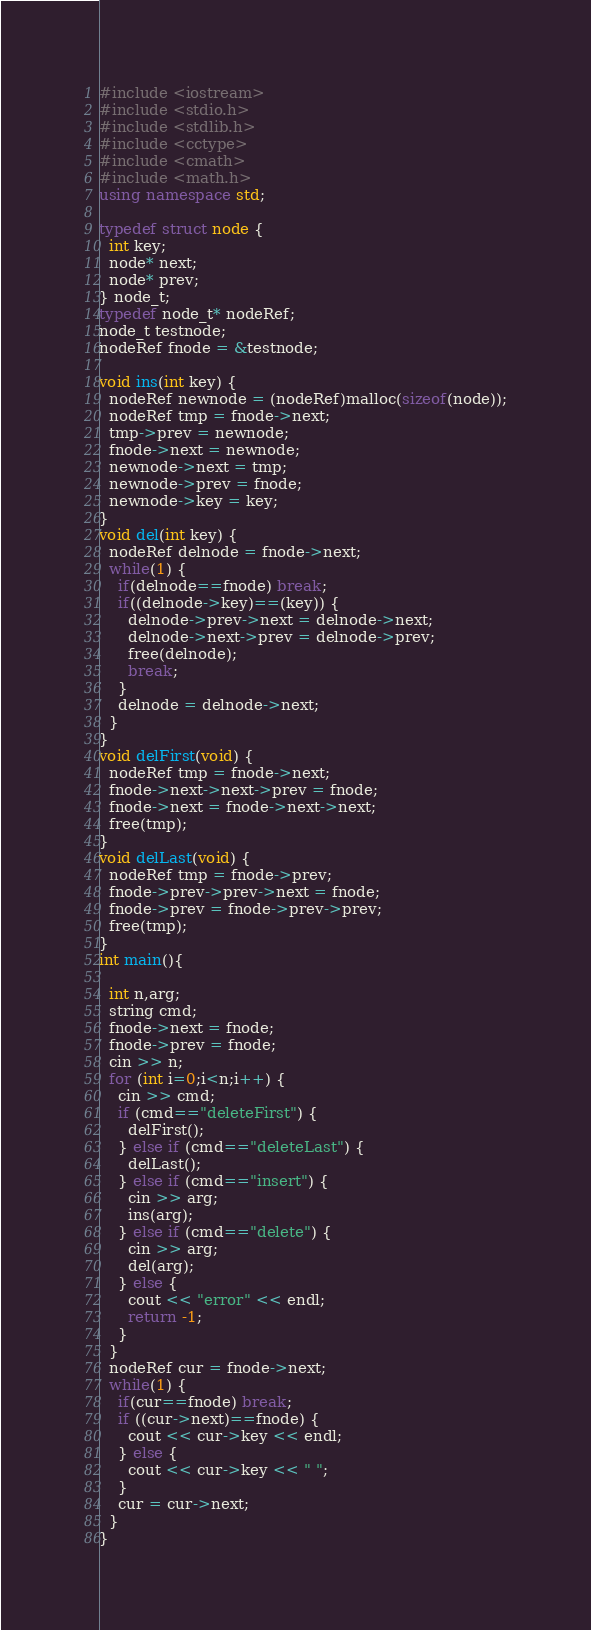Convert code to text. <code><loc_0><loc_0><loc_500><loc_500><_C++_>#include <iostream>
#include <stdio.h>
#include <stdlib.h>
#include <cctype>
#include <cmath>
#include <math.h>
using namespace std;

typedef struct node {
  int key;
  node* next;
  node* prev;
} node_t;
typedef node_t* nodeRef;
node_t testnode;
nodeRef fnode = &testnode;

void ins(int key) {
  nodeRef newnode = (nodeRef)malloc(sizeof(node));
  nodeRef tmp = fnode->next;
  tmp->prev = newnode;
  fnode->next = newnode;
  newnode->next = tmp;
  newnode->prev = fnode;
  newnode->key = key;
}
void del(int key) {
  nodeRef delnode = fnode->next;
  while(1) {
    if(delnode==fnode) break;
    if((delnode->key)==(key)) {
      delnode->prev->next = delnode->next;
      delnode->next->prev = delnode->prev;
      free(delnode);
      break;
    }
    delnode = delnode->next;
  }
}
void delFirst(void) {
  nodeRef tmp = fnode->next;
  fnode->next->next->prev = fnode;
  fnode->next = fnode->next->next;
  free(tmp);
}
void delLast(void) {
  nodeRef tmp = fnode->prev;
  fnode->prev->prev->next = fnode;
  fnode->prev = fnode->prev->prev;
  free(tmp);
}
int main(){

  int n,arg;
  string cmd;
  fnode->next = fnode;
  fnode->prev = fnode;
  cin >> n;
  for (int i=0;i<n;i++) {
    cin >> cmd;
    if (cmd=="deleteFirst") {
      delFirst();
    } else if (cmd=="deleteLast") {
      delLast();
    } else if (cmd=="insert") {
      cin >> arg;
      ins(arg);
    } else if (cmd=="delete") {
      cin >> arg;
      del(arg);
    } else {
      cout << "error" << endl;
      return -1;
    }
  }
  nodeRef cur = fnode->next;
  while(1) {
    if(cur==fnode) break;
    if ((cur->next)==fnode) {
      cout << cur->key << endl;
    } else {
      cout << cur->key << " ";
    }
    cur = cur->next;
  }
}

</code> 